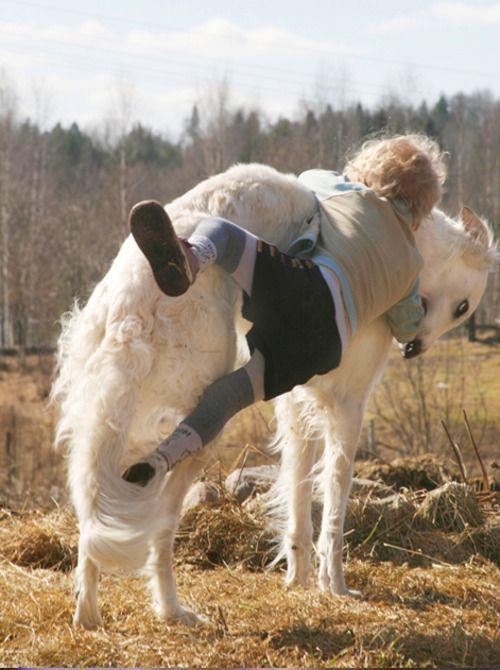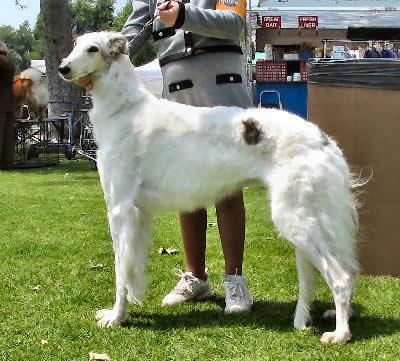The first image is the image on the left, the second image is the image on the right. Given the left and right images, does the statement "An image shows exactly two hounds." hold true? Answer yes or no. No. 